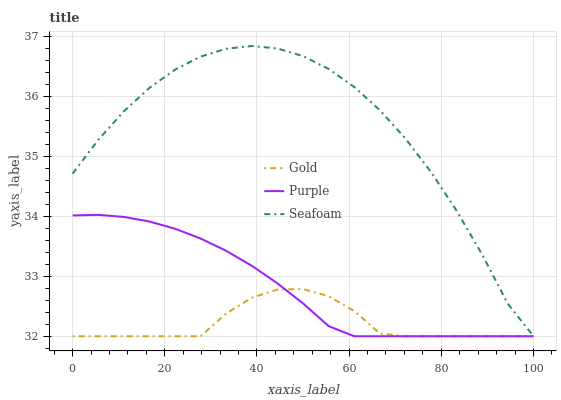Does Gold have the minimum area under the curve?
Answer yes or no. Yes. Does Seafoam have the maximum area under the curve?
Answer yes or no. Yes. Does Seafoam have the minimum area under the curve?
Answer yes or no. No. Does Gold have the maximum area under the curve?
Answer yes or no. No. Is Purple the smoothest?
Answer yes or no. Yes. Is Seafoam the roughest?
Answer yes or no. Yes. Is Gold the smoothest?
Answer yes or no. No. Is Gold the roughest?
Answer yes or no. No. Does Purple have the lowest value?
Answer yes or no. Yes. Does Seafoam have the highest value?
Answer yes or no. Yes. Does Gold have the highest value?
Answer yes or no. No. Does Seafoam intersect Purple?
Answer yes or no. Yes. Is Seafoam less than Purple?
Answer yes or no. No. Is Seafoam greater than Purple?
Answer yes or no. No. 